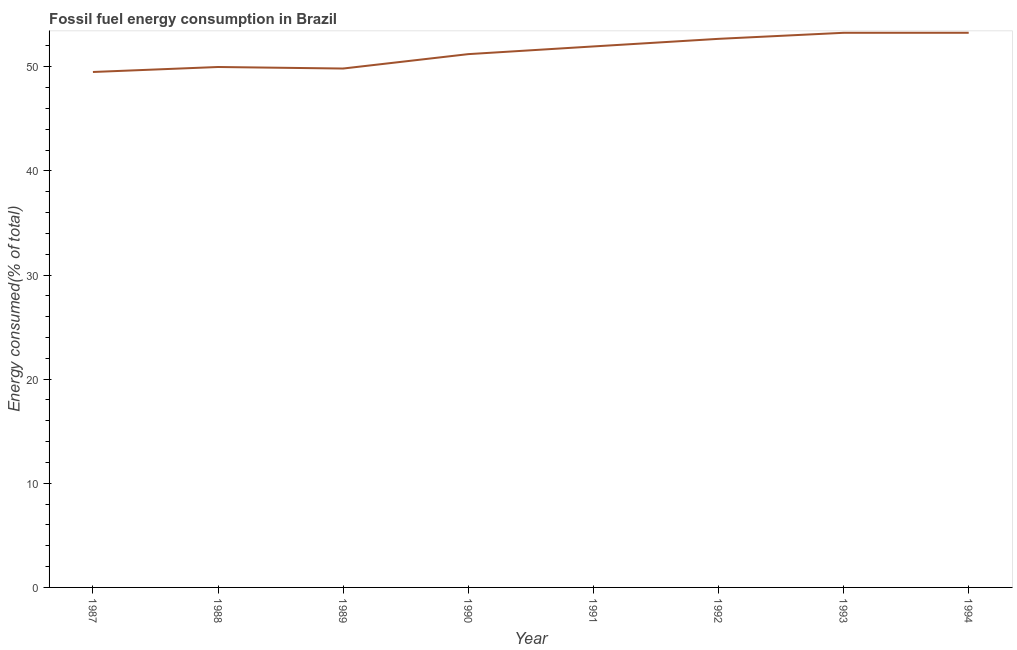What is the fossil fuel energy consumption in 1987?
Offer a terse response. 49.5. Across all years, what is the maximum fossil fuel energy consumption?
Offer a very short reply. 53.27. Across all years, what is the minimum fossil fuel energy consumption?
Your response must be concise. 49.5. In which year was the fossil fuel energy consumption maximum?
Your response must be concise. 1994. What is the sum of the fossil fuel energy consumption?
Make the answer very short. 411.7. What is the difference between the fossil fuel energy consumption in 1990 and 1994?
Provide a succinct answer. -2.05. What is the average fossil fuel energy consumption per year?
Your answer should be compact. 51.46. What is the median fossil fuel energy consumption?
Make the answer very short. 51.59. Do a majority of the years between 1987 and 1989 (inclusive) have fossil fuel energy consumption greater than 22 %?
Your answer should be very brief. Yes. What is the ratio of the fossil fuel energy consumption in 1988 to that in 1991?
Offer a terse response. 0.96. What is the difference between the highest and the second highest fossil fuel energy consumption?
Your answer should be compact. 0. What is the difference between the highest and the lowest fossil fuel energy consumption?
Your response must be concise. 3.76. In how many years, is the fossil fuel energy consumption greater than the average fossil fuel energy consumption taken over all years?
Provide a succinct answer. 4. How many lines are there?
Your response must be concise. 1. How many years are there in the graph?
Your response must be concise. 8. Does the graph contain grids?
Ensure brevity in your answer.  No. What is the title of the graph?
Offer a very short reply. Fossil fuel energy consumption in Brazil. What is the label or title of the X-axis?
Offer a terse response. Year. What is the label or title of the Y-axis?
Your response must be concise. Energy consumed(% of total). What is the Energy consumed(% of total) of 1987?
Your response must be concise. 49.5. What is the Energy consumed(% of total) in 1988?
Keep it short and to the point. 49.98. What is the Energy consumed(% of total) of 1989?
Make the answer very short. 49.83. What is the Energy consumed(% of total) of 1990?
Provide a succinct answer. 51.22. What is the Energy consumed(% of total) of 1991?
Provide a short and direct response. 51.95. What is the Energy consumed(% of total) in 1992?
Your answer should be very brief. 52.68. What is the Energy consumed(% of total) of 1993?
Your answer should be compact. 53.26. What is the Energy consumed(% of total) in 1994?
Ensure brevity in your answer.  53.27. What is the difference between the Energy consumed(% of total) in 1987 and 1988?
Ensure brevity in your answer.  -0.48. What is the difference between the Energy consumed(% of total) in 1987 and 1989?
Provide a short and direct response. -0.33. What is the difference between the Energy consumed(% of total) in 1987 and 1990?
Your answer should be very brief. -1.71. What is the difference between the Energy consumed(% of total) in 1987 and 1991?
Offer a very short reply. -2.45. What is the difference between the Energy consumed(% of total) in 1987 and 1992?
Offer a terse response. -3.18. What is the difference between the Energy consumed(% of total) in 1987 and 1993?
Offer a very short reply. -3.76. What is the difference between the Energy consumed(% of total) in 1987 and 1994?
Provide a short and direct response. -3.76. What is the difference between the Energy consumed(% of total) in 1988 and 1989?
Make the answer very short. 0.15. What is the difference between the Energy consumed(% of total) in 1988 and 1990?
Provide a short and direct response. -1.24. What is the difference between the Energy consumed(% of total) in 1988 and 1991?
Your response must be concise. -1.97. What is the difference between the Energy consumed(% of total) in 1988 and 1992?
Provide a succinct answer. -2.7. What is the difference between the Energy consumed(% of total) in 1988 and 1993?
Offer a terse response. -3.28. What is the difference between the Energy consumed(% of total) in 1988 and 1994?
Your answer should be very brief. -3.29. What is the difference between the Energy consumed(% of total) in 1989 and 1990?
Keep it short and to the point. -1.38. What is the difference between the Energy consumed(% of total) in 1989 and 1991?
Offer a very short reply. -2.12. What is the difference between the Energy consumed(% of total) in 1989 and 1992?
Offer a very short reply. -2.85. What is the difference between the Energy consumed(% of total) in 1989 and 1993?
Make the answer very short. -3.43. What is the difference between the Energy consumed(% of total) in 1989 and 1994?
Keep it short and to the point. -3.43. What is the difference between the Energy consumed(% of total) in 1990 and 1991?
Make the answer very short. -0.74. What is the difference between the Energy consumed(% of total) in 1990 and 1992?
Provide a short and direct response. -1.47. What is the difference between the Energy consumed(% of total) in 1990 and 1993?
Provide a succinct answer. -2.05. What is the difference between the Energy consumed(% of total) in 1990 and 1994?
Your answer should be very brief. -2.05. What is the difference between the Energy consumed(% of total) in 1991 and 1992?
Your answer should be compact. -0.73. What is the difference between the Energy consumed(% of total) in 1991 and 1993?
Provide a succinct answer. -1.31. What is the difference between the Energy consumed(% of total) in 1991 and 1994?
Ensure brevity in your answer.  -1.31. What is the difference between the Energy consumed(% of total) in 1992 and 1993?
Keep it short and to the point. -0.58. What is the difference between the Energy consumed(% of total) in 1992 and 1994?
Your answer should be very brief. -0.58. What is the difference between the Energy consumed(% of total) in 1993 and 1994?
Make the answer very short. -0. What is the ratio of the Energy consumed(% of total) in 1987 to that in 1988?
Give a very brief answer. 0.99. What is the ratio of the Energy consumed(% of total) in 1987 to that in 1989?
Offer a terse response. 0.99. What is the ratio of the Energy consumed(% of total) in 1987 to that in 1990?
Ensure brevity in your answer.  0.97. What is the ratio of the Energy consumed(% of total) in 1987 to that in 1991?
Ensure brevity in your answer.  0.95. What is the ratio of the Energy consumed(% of total) in 1987 to that in 1992?
Provide a succinct answer. 0.94. What is the ratio of the Energy consumed(% of total) in 1987 to that in 1993?
Your answer should be very brief. 0.93. What is the ratio of the Energy consumed(% of total) in 1987 to that in 1994?
Offer a terse response. 0.93. What is the ratio of the Energy consumed(% of total) in 1988 to that in 1991?
Your answer should be compact. 0.96. What is the ratio of the Energy consumed(% of total) in 1988 to that in 1992?
Offer a terse response. 0.95. What is the ratio of the Energy consumed(% of total) in 1988 to that in 1993?
Make the answer very short. 0.94. What is the ratio of the Energy consumed(% of total) in 1988 to that in 1994?
Your response must be concise. 0.94. What is the ratio of the Energy consumed(% of total) in 1989 to that in 1990?
Offer a terse response. 0.97. What is the ratio of the Energy consumed(% of total) in 1989 to that in 1991?
Ensure brevity in your answer.  0.96. What is the ratio of the Energy consumed(% of total) in 1989 to that in 1992?
Your answer should be compact. 0.95. What is the ratio of the Energy consumed(% of total) in 1989 to that in 1993?
Make the answer very short. 0.94. What is the ratio of the Energy consumed(% of total) in 1989 to that in 1994?
Give a very brief answer. 0.94. What is the ratio of the Energy consumed(% of total) in 1990 to that in 1992?
Keep it short and to the point. 0.97. What is the ratio of the Energy consumed(% of total) in 1990 to that in 1993?
Offer a very short reply. 0.96. What is the ratio of the Energy consumed(% of total) in 1990 to that in 1994?
Your answer should be compact. 0.96. What is the ratio of the Energy consumed(% of total) in 1991 to that in 1994?
Offer a terse response. 0.97. What is the ratio of the Energy consumed(% of total) in 1992 to that in 1993?
Your answer should be very brief. 0.99. What is the ratio of the Energy consumed(% of total) in 1993 to that in 1994?
Your answer should be compact. 1. 